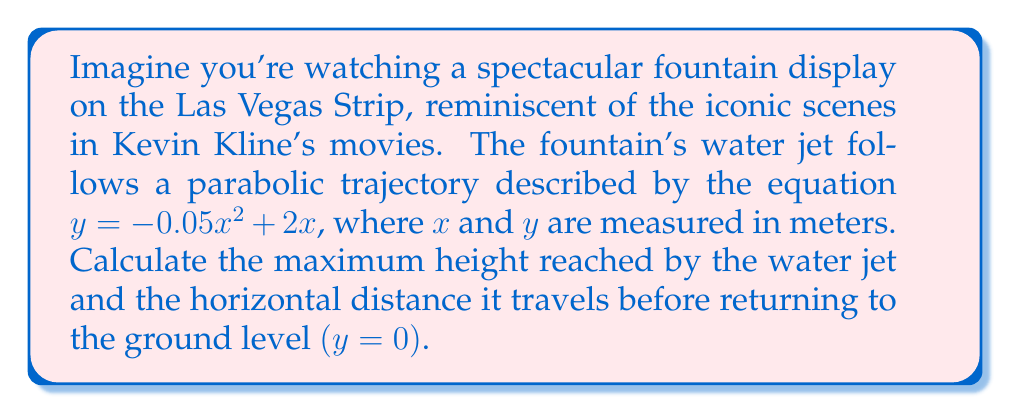Show me your answer to this math problem. Let's approach this problem step by step:

1) The water jet's trajectory is described by the quadratic equation:
   $y = -0.05x^2 + 2x$

2) To find the maximum height, we need to find the vertex of this parabola. For a quadratic equation in the form $y = ax^2 + bx + c$, the x-coordinate of the vertex is given by $x = -\frac{b}{2a}$.

3) In our case, $a = -0.05$ and $b = 2$. So:
   $x = -\frac{2}{2(-0.05)} = \frac{2}{0.1} = 20$ meters

4) To find the y-coordinate (maximum height), we substitute this x-value back into our original equation:
   $y = -0.05(20)^2 + 2(20)$
   $y = -0.05(400) + 40$
   $y = -20 + 40 = 20$ meters

5) For the horizontal distance, we need to find the positive root of the equation when $y = 0$:
   $0 = -0.05x^2 + 2x$
   $0.05x^2 - 2x = 0$
   $x(0.05x - 2) = 0$

6) Solving this, we get $x = 0$ or $x = 40$. The positive root, 40, gives us the horizontal distance.

[asy]
import graph;
size(200,200);
real f(real x) {return -0.05x^2+2x;}
draw(graph(f,0,40),blue);
draw((0,0)--(40,0),dashed);
draw((20,0)--(20,20),dashed);
label("(20,20)",((20,20)),NE);
label("(40,0)",((40,0)),SE);
label("x (m)",((40,0)),S);
label("y (m)",((0,20)),W);
[/asy]
Answer: The water jet reaches a maximum height of 20 meters and travels a horizontal distance of 40 meters. 